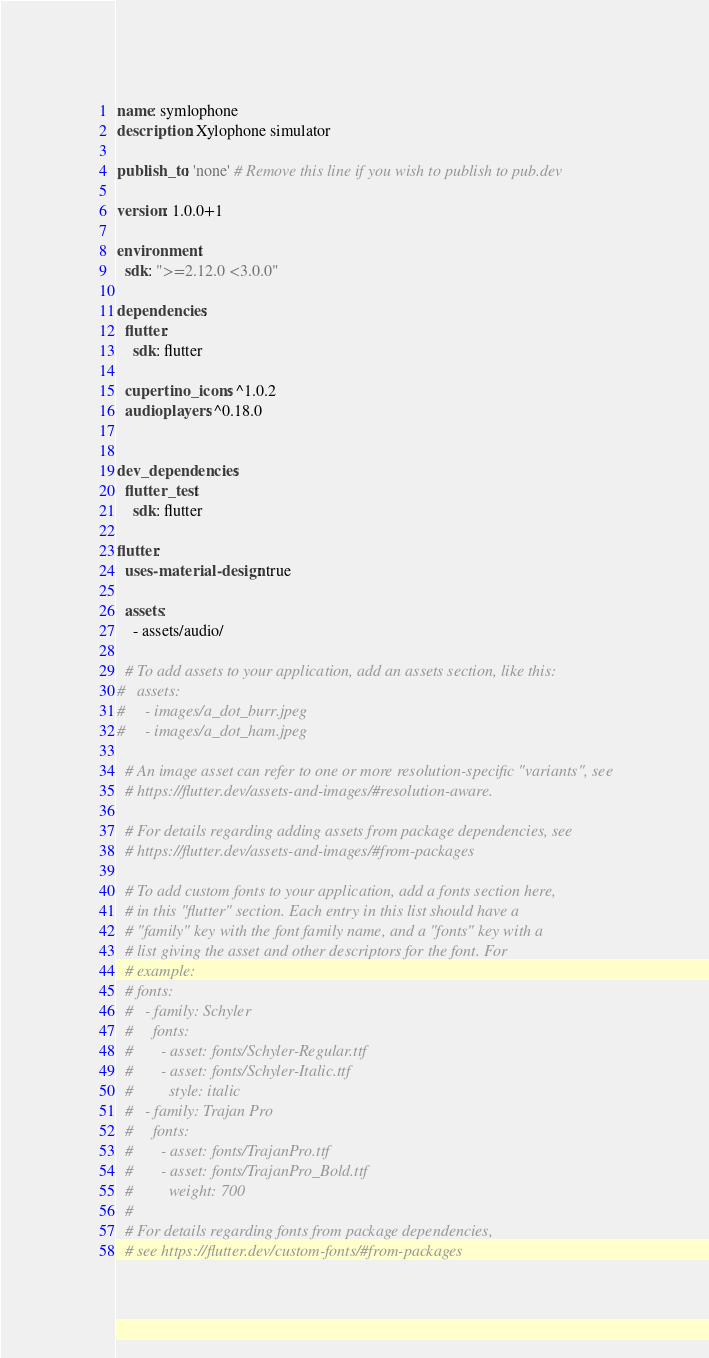<code> <loc_0><loc_0><loc_500><loc_500><_YAML_>name: symlophone
description: Xylophone simulator

publish_to: 'none' # Remove this line if you wish to publish to pub.dev

version: 1.0.0+1

environment:
  sdk: ">=2.12.0 <3.0.0"

dependencies:
  flutter:
    sdk: flutter

  cupertino_icons: ^1.0.2
  audioplayers: ^0.18.0


dev_dependencies:
  flutter_test:
    sdk: flutter

flutter:
  uses-material-design: true

  assets:
    - assets/audio/

  # To add assets to your application, add an assets section, like this:
#   assets:
#     - images/a_dot_burr.jpeg
#     - images/a_dot_ham.jpeg

  # An image asset can refer to one or more resolution-specific "variants", see
  # https://flutter.dev/assets-and-images/#resolution-aware.

  # For details regarding adding assets from package dependencies, see
  # https://flutter.dev/assets-and-images/#from-packages

  # To add custom fonts to your application, add a fonts section here,
  # in this "flutter" section. Each entry in this list should have a
  # "family" key with the font family name, and a "fonts" key with a
  # list giving the asset and other descriptors for the font. For
  # example:
  # fonts:
  #   - family: Schyler
  #     fonts:
  #       - asset: fonts/Schyler-Regular.ttf
  #       - asset: fonts/Schyler-Italic.ttf
  #         style: italic
  #   - family: Trajan Pro
  #     fonts:
  #       - asset: fonts/TrajanPro.ttf
  #       - asset: fonts/TrajanPro_Bold.ttf
  #         weight: 700
  #
  # For details regarding fonts from package dependencies,
  # see https://flutter.dev/custom-fonts/#from-packages
</code> 